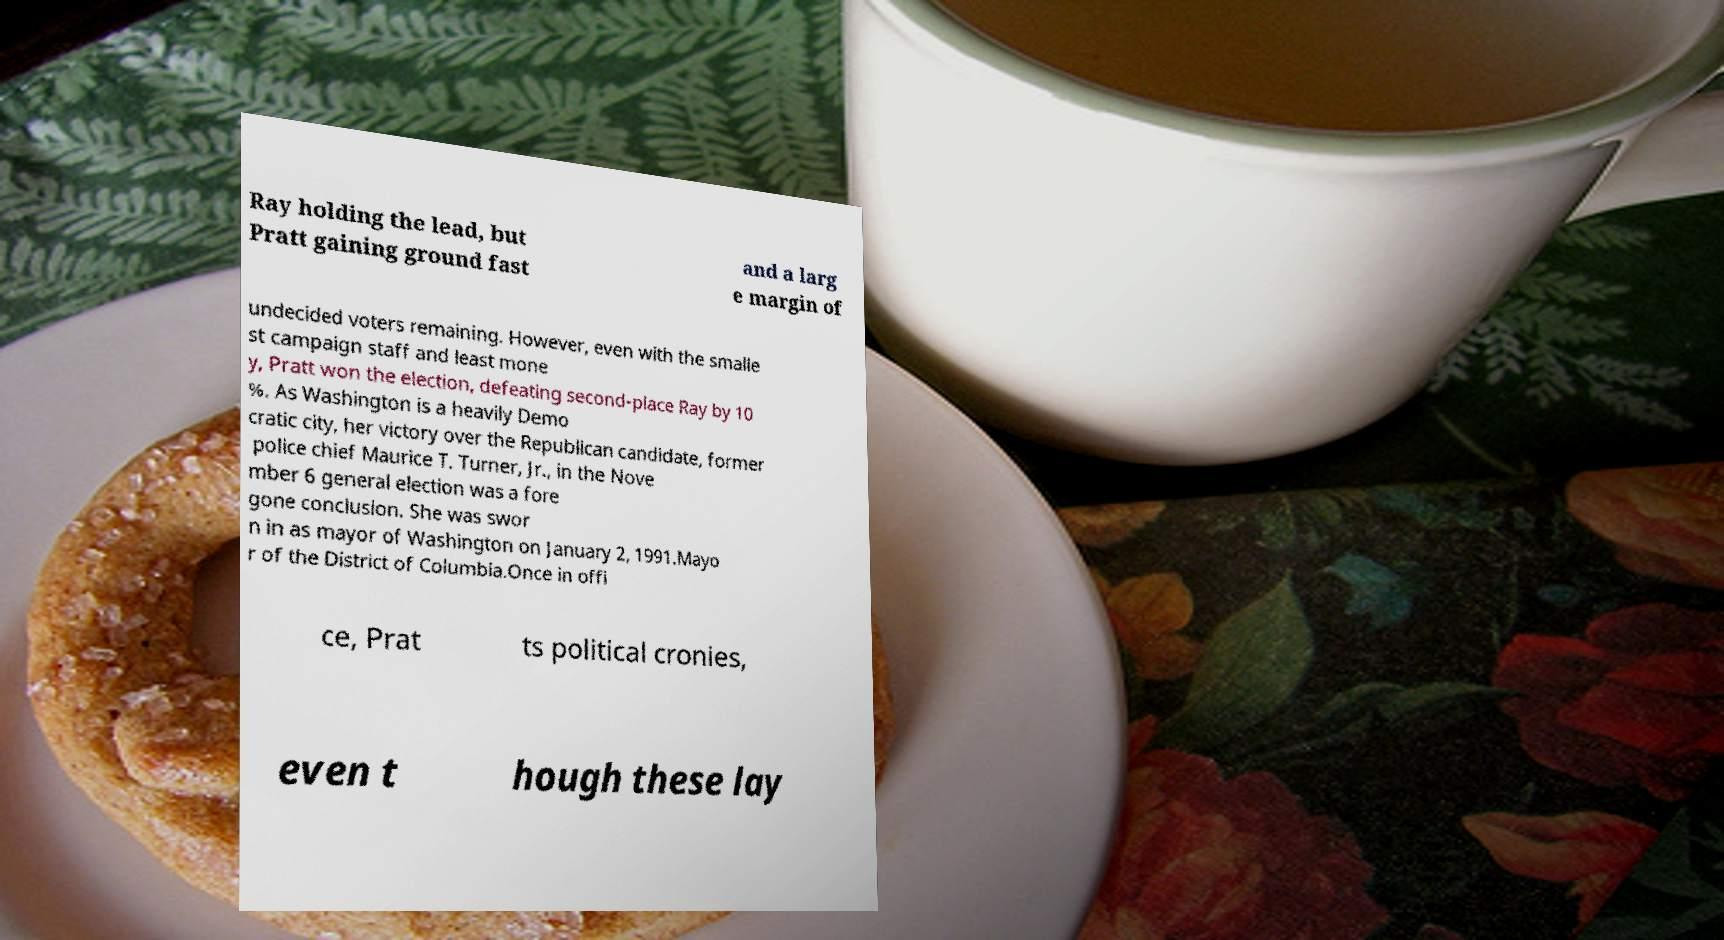I need the written content from this picture converted into text. Can you do that? Ray holding the lead, but Pratt gaining ground fast and a larg e margin of undecided voters remaining. However, even with the smalle st campaign staff and least mone y, Pratt won the election, defeating second-place Ray by 10 %. As Washington is a heavily Demo cratic city, her victory over the Republican candidate, former police chief Maurice T. Turner, Jr., in the Nove mber 6 general election was a fore gone conclusion. She was swor n in as mayor of Washington on January 2, 1991.Mayo r of the District of Columbia.Once in offi ce, Prat ts political cronies, even t hough these lay 